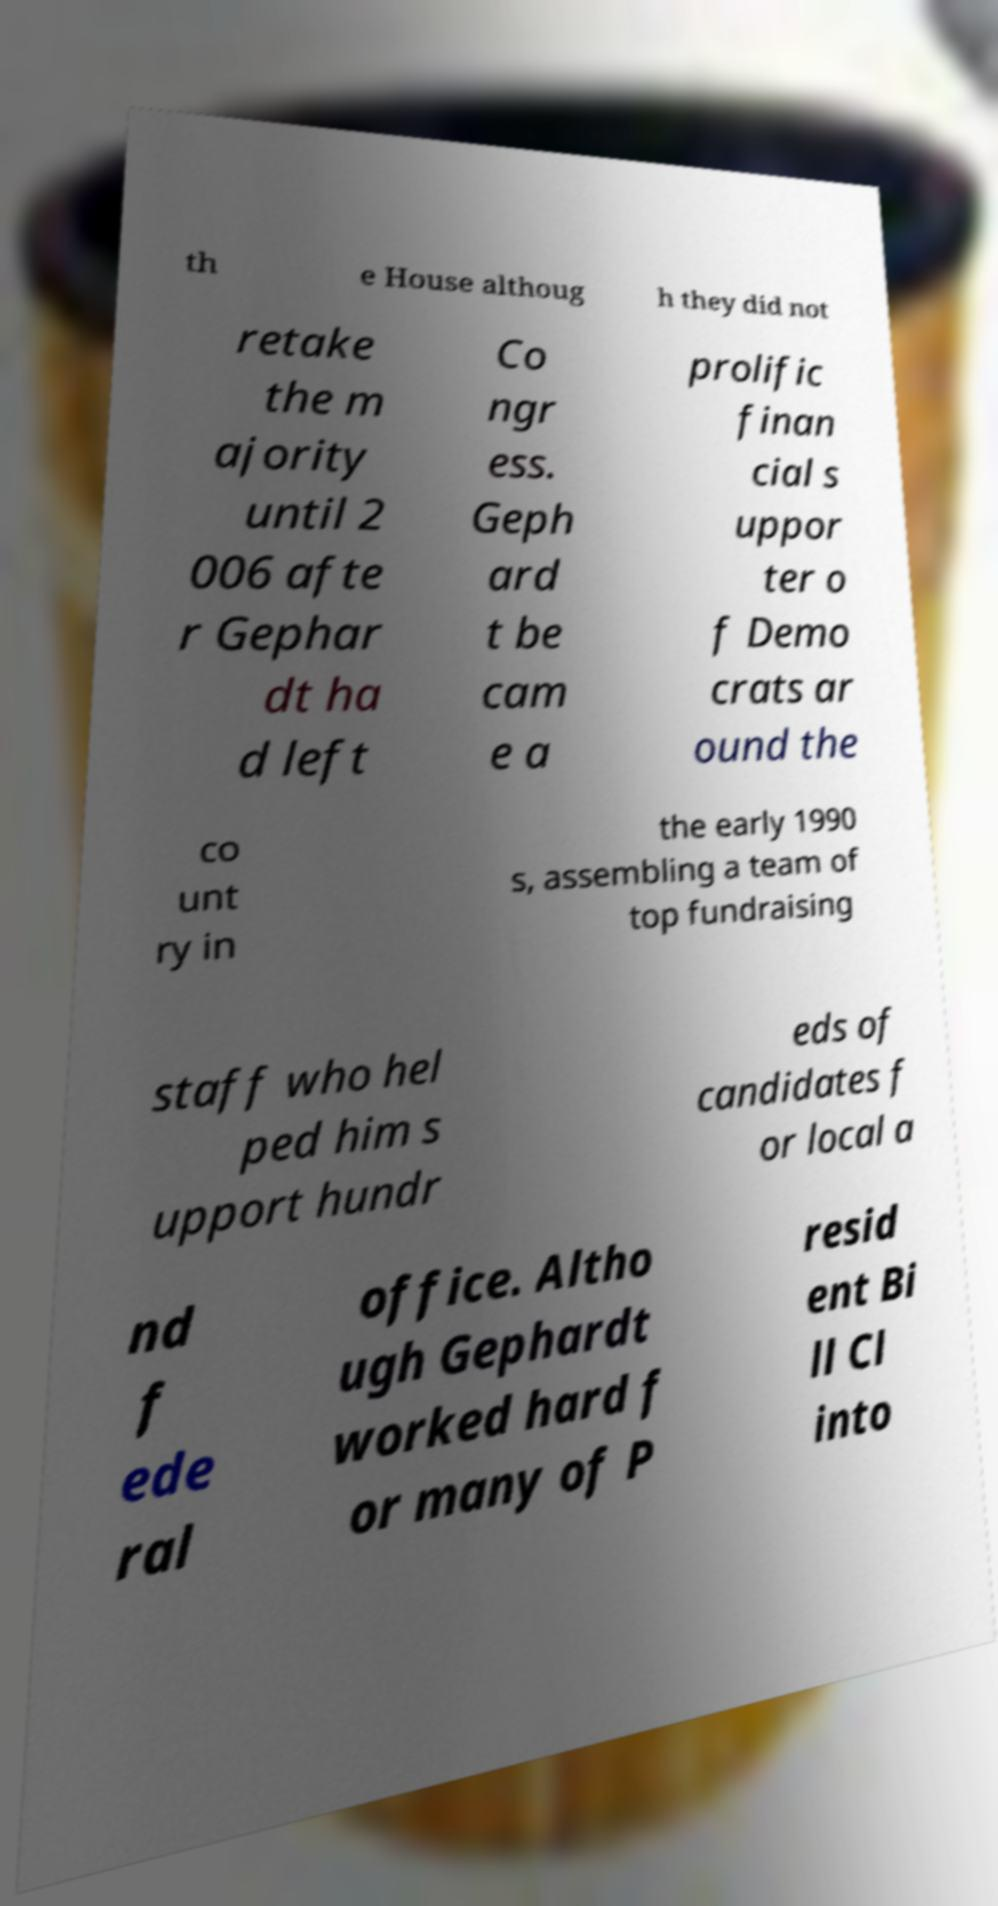What messages or text are displayed in this image? I need them in a readable, typed format. th e House althoug h they did not retake the m ajority until 2 006 afte r Gephar dt ha d left Co ngr ess. Geph ard t be cam e a prolific finan cial s uppor ter o f Demo crats ar ound the co unt ry in the early 1990 s, assembling a team of top fundraising staff who hel ped him s upport hundr eds of candidates f or local a nd f ede ral office. Altho ugh Gephardt worked hard f or many of P resid ent Bi ll Cl into 